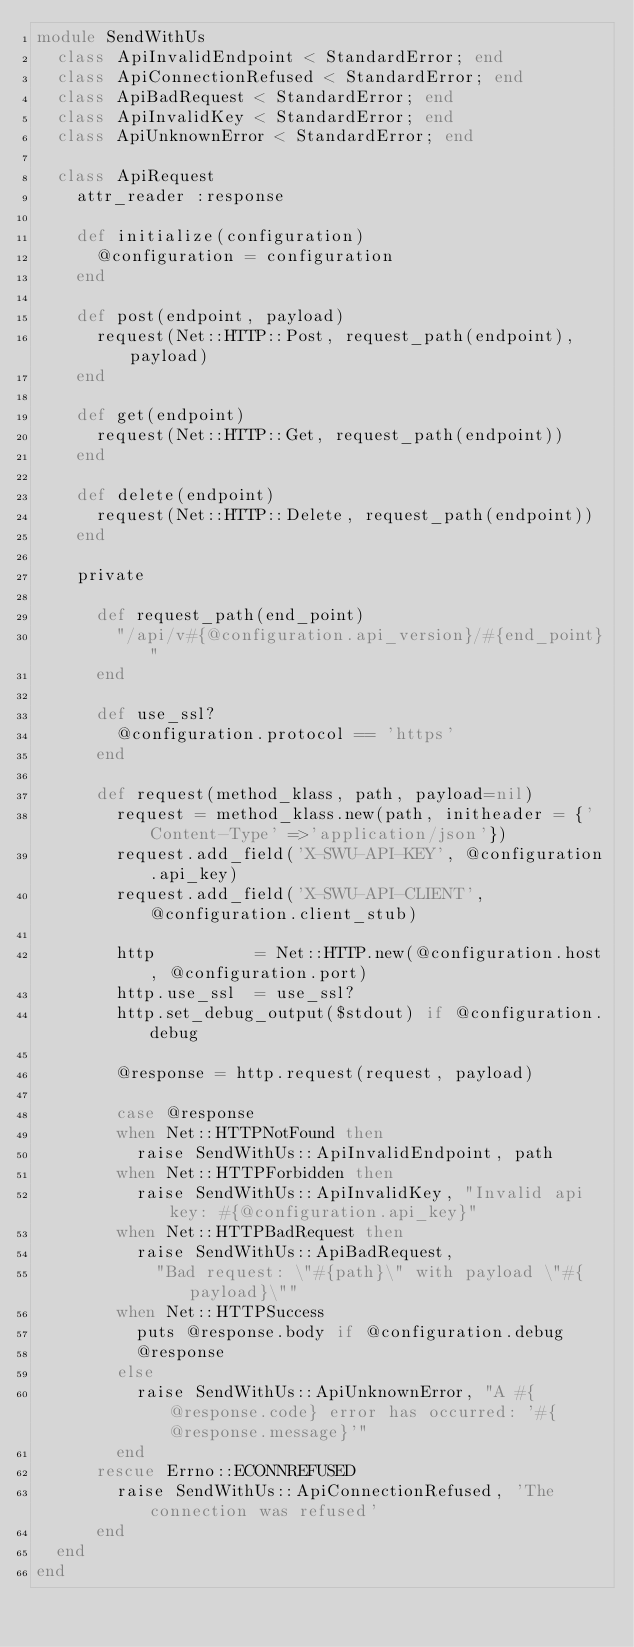<code> <loc_0><loc_0><loc_500><loc_500><_Ruby_>module SendWithUs
  class ApiInvalidEndpoint < StandardError; end
  class ApiConnectionRefused < StandardError; end
  class ApiBadRequest < StandardError; end
  class ApiInvalidKey < StandardError; end
  class ApiUnknownError < StandardError; end

  class ApiRequest
    attr_reader :response

    def initialize(configuration)
      @configuration = configuration
    end

    def post(endpoint, payload)
      request(Net::HTTP::Post, request_path(endpoint), payload)
    end

    def get(endpoint)
      request(Net::HTTP::Get, request_path(endpoint))
    end
    
    def delete(endpoint)
      request(Net::HTTP::Delete, request_path(endpoint))
    end

    private

      def request_path(end_point)
        "/api/v#{@configuration.api_version}/#{end_point}"
      end

      def use_ssl?
        @configuration.protocol == 'https'
      end

      def request(method_klass, path, payload=nil)
        request = method_klass.new(path, initheader = {'Content-Type' =>'application/json'})
        request.add_field('X-SWU-API-KEY', @configuration.api_key)
        request.add_field('X-SWU-API-CLIENT', @configuration.client_stub)

        http          = Net::HTTP.new(@configuration.host, @configuration.port)
        http.use_ssl  = use_ssl?
        http.set_debug_output($stdout) if @configuration.debug

        @response = http.request(request, payload)

        case @response
        when Net::HTTPNotFound then
          raise SendWithUs::ApiInvalidEndpoint, path
        when Net::HTTPForbidden then
          raise SendWithUs::ApiInvalidKey, "Invalid api key: #{@configuration.api_key}"
        when Net::HTTPBadRequest then
          raise SendWithUs::ApiBadRequest,
            "Bad request: \"#{path}\" with payload \"#{payload}\""
        when Net::HTTPSuccess
          puts @response.body if @configuration.debug
          @response
        else
          raise SendWithUs::ApiUnknownError, "A #{@response.code} error has occurred: '#{@response.message}'"
        end
      rescue Errno::ECONNREFUSED
        raise SendWithUs::ApiConnectionRefused, 'The connection was refused'
      end
  end
end
</code> 